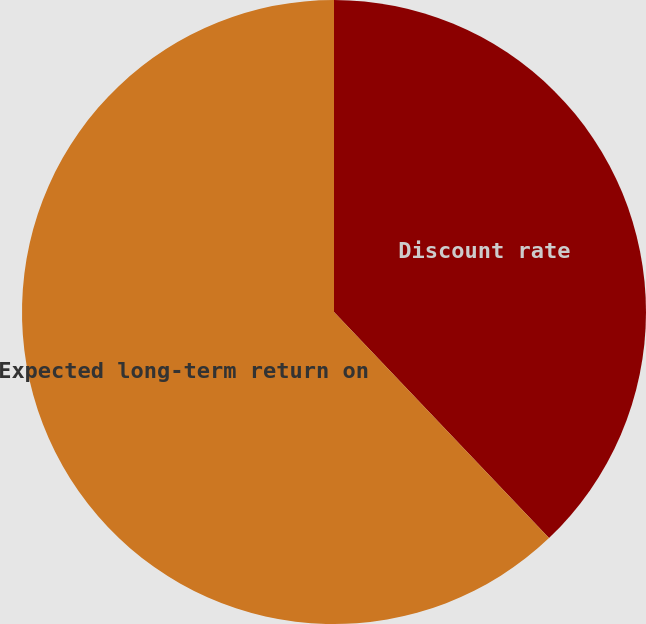Convert chart. <chart><loc_0><loc_0><loc_500><loc_500><pie_chart><fcel>Discount rate<fcel>Expected long-term return on<nl><fcel>37.9%<fcel>62.1%<nl></chart> 